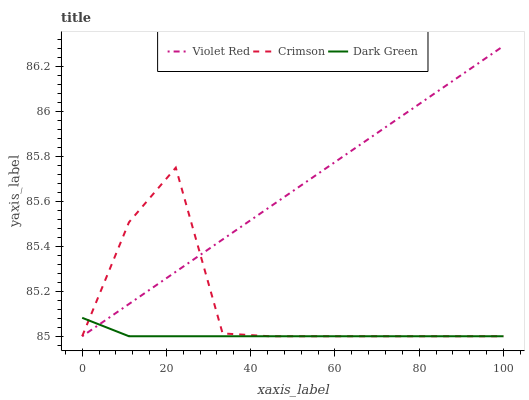Does Violet Red have the minimum area under the curve?
Answer yes or no. No. Does Dark Green have the maximum area under the curve?
Answer yes or no. No. Is Dark Green the smoothest?
Answer yes or no. No. Is Dark Green the roughest?
Answer yes or no. No. Does Dark Green have the highest value?
Answer yes or no. No. 